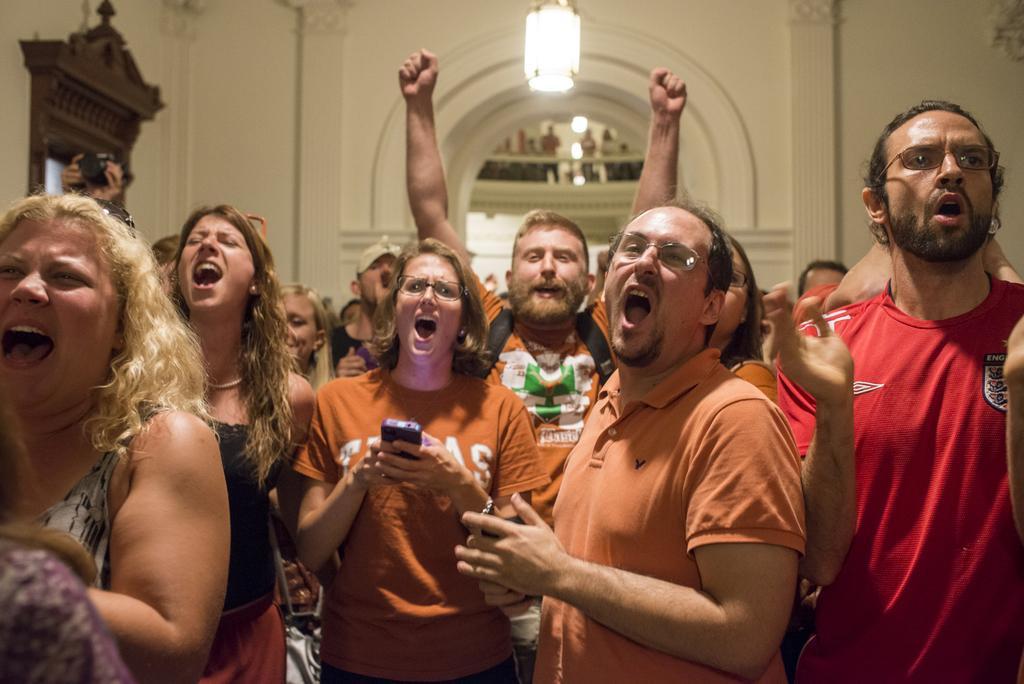How would you summarize this image in a sentence or two? In this image there are people standing and shouting, in the background there is a wall, for that wall there is an entrance, at the top there is a light. 